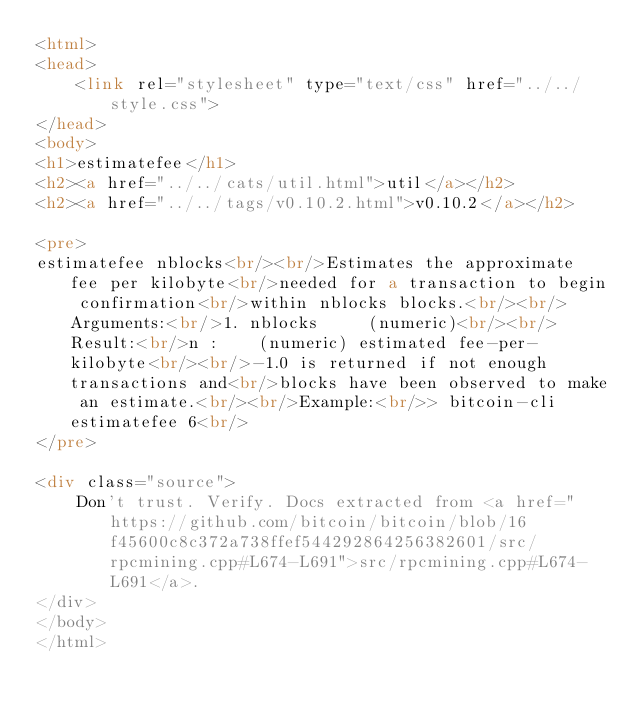Convert code to text. <code><loc_0><loc_0><loc_500><loc_500><_HTML_><html>
<head>
    <link rel="stylesheet" type="text/css" href="../../style.css">
</head>
<body>
<h1>estimatefee</h1>
<h2><a href="../../cats/util.html">util</a></h2>
<h2><a href="../../tags/v0.10.2.html">v0.10.2</a></h2>

<pre>
estimatefee nblocks<br/><br/>Estimates the approximate fee per kilobyte<br/>needed for a transaction to begin confirmation<br/>within nblocks blocks.<br/><br/>Arguments:<br/>1. nblocks     (numeric)<br/><br/>Result:<br/>n :    (numeric) estimated fee-per-kilobyte<br/><br/>-1.0 is returned if not enough transactions and<br/>blocks have been observed to make an estimate.<br/><br/>Example:<br/>> bitcoin-cli estimatefee 6<br/>
</pre>

<div class="source">
    Don't trust. Verify. Docs extracted from <a href="https://github.com/bitcoin/bitcoin/blob/16f45600c8c372a738ffef544292864256382601/src/rpcmining.cpp#L674-L691">src/rpcmining.cpp#L674-L691</a>.
</div>
</body>
</html>
</code> 